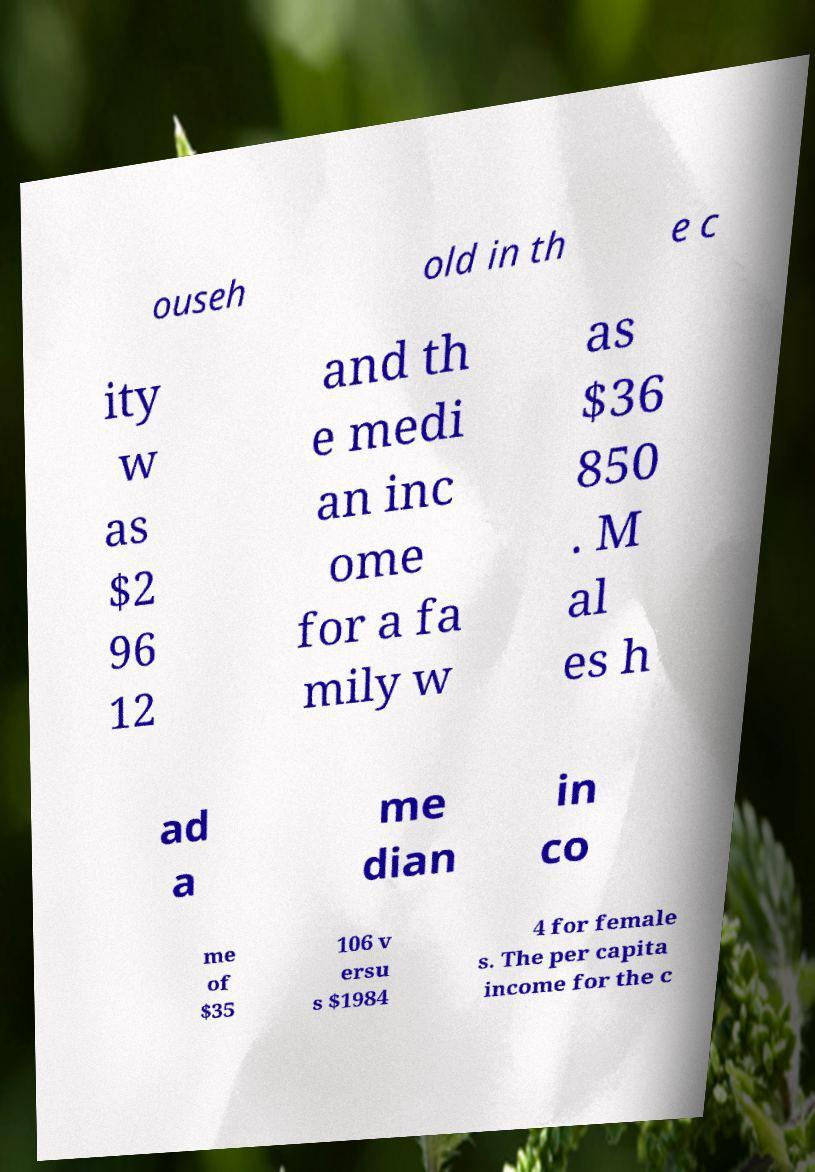Could you extract and type out the text from this image? ouseh old in th e c ity w as $2 96 12 and th e medi an inc ome for a fa mily w as $36 850 . M al es h ad a me dian in co me of $35 106 v ersu s $1984 4 for female s. The per capita income for the c 